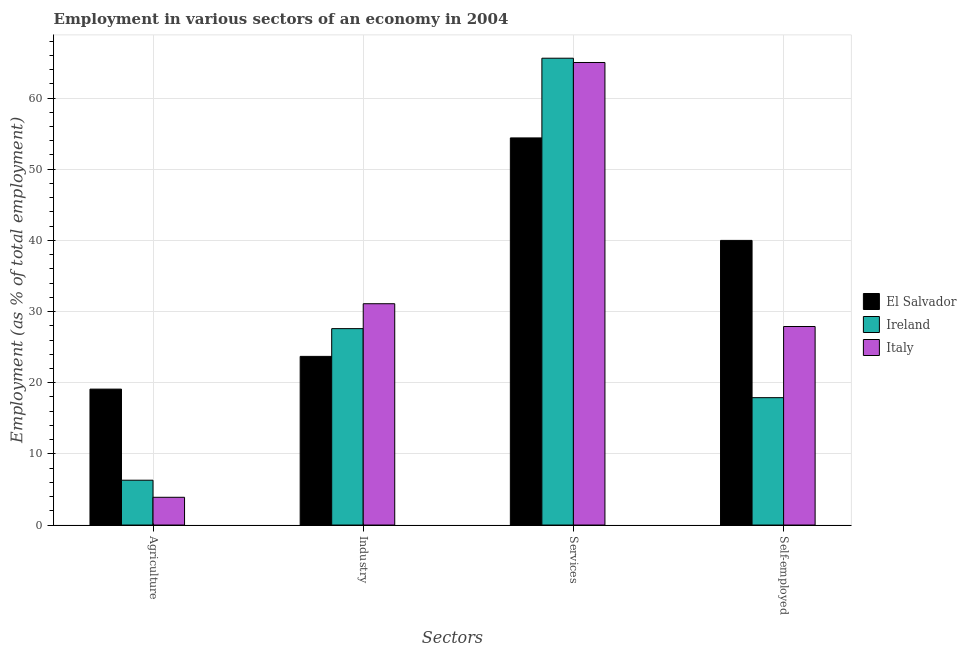How many groups of bars are there?
Offer a terse response. 4. Are the number of bars per tick equal to the number of legend labels?
Provide a succinct answer. Yes. Are the number of bars on each tick of the X-axis equal?
Your answer should be very brief. Yes. How many bars are there on the 1st tick from the left?
Keep it short and to the point. 3. What is the label of the 4th group of bars from the left?
Give a very brief answer. Self-employed. Across all countries, what is the maximum percentage of workers in agriculture?
Keep it short and to the point. 19.1. Across all countries, what is the minimum percentage of workers in industry?
Keep it short and to the point. 23.7. In which country was the percentage of workers in services maximum?
Give a very brief answer. Ireland. In which country was the percentage of workers in services minimum?
Offer a very short reply. El Salvador. What is the total percentage of self employed workers in the graph?
Offer a terse response. 85.8. What is the difference between the percentage of workers in agriculture in Italy and that in El Salvador?
Provide a succinct answer. -15.2. What is the difference between the percentage of workers in industry in Ireland and the percentage of self employed workers in El Salvador?
Offer a terse response. -12.4. What is the average percentage of workers in agriculture per country?
Provide a short and direct response. 9.77. What is the difference between the percentage of workers in services and percentage of workers in industry in Ireland?
Your response must be concise. 38. What is the ratio of the percentage of workers in agriculture in Ireland to that in El Salvador?
Your response must be concise. 0.33. Is the difference between the percentage of workers in agriculture in El Salvador and Italy greater than the difference between the percentage of workers in services in El Salvador and Italy?
Make the answer very short. Yes. What is the difference between the highest and the second highest percentage of self employed workers?
Your answer should be very brief. 12.1. What is the difference between the highest and the lowest percentage of self employed workers?
Your answer should be very brief. 22.1. In how many countries, is the percentage of workers in agriculture greater than the average percentage of workers in agriculture taken over all countries?
Give a very brief answer. 1. Is it the case that in every country, the sum of the percentage of workers in industry and percentage of workers in services is greater than the sum of percentage of workers in agriculture and percentage of self employed workers?
Your answer should be very brief. No. What does the 1st bar from the left in Services represents?
Your response must be concise. El Salvador. How many bars are there?
Your answer should be very brief. 12. Are all the bars in the graph horizontal?
Give a very brief answer. No. How many countries are there in the graph?
Your response must be concise. 3. What is the difference between two consecutive major ticks on the Y-axis?
Your answer should be compact. 10. Does the graph contain any zero values?
Offer a terse response. No. Does the graph contain grids?
Ensure brevity in your answer.  Yes. What is the title of the graph?
Provide a succinct answer. Employment in various sectors of an economy in 2004. What is the label or title of the X-axis?
Provide a succinct answer. Sectors. What is the label or title of the Y-axis?
Keep it short and to the point. Employment (as % of total employment). What is the Employment (as % of total employment) of El Salvador in Agriculture?
Your answer should be very brief. 19.1. What is the Employment (as % of total employment) in Ireland in Agriculture?
Offer a very short reply. 6.3. What is the Employment (as % of total employment) in Italy in Agriculture?
Provide a succinct answer. 3.9. What is the Employment (as % of total employment) in El Salvador in Industry?
Ensure brevity in your answer.  23.7. What is the Employment (as % of total employment) in Ireland in Industry?
Provide a short and direct response. 27.6. What is the Employment (as % of total employment) of Italy in Industry?
Make the answer very short. 31.1. What is the Employment (as % of total employment) of El Salvador in Services?
Provide a succinct answer. 54.4. What is the Employment (as % of total employment) in Ireland in Services?
Offer a terse response. 65.6. What is the Employment (as % of total employment) of El Salvador in Self-employed?
Your answer should be very brief. 40. What is the Employment (as % of total employment) of Ireland in Self-employed?
Your answer should be very brief. 17.9. What is the Employment (as % of total employment) in Italy in Self-employed?
Offer a terse response. 27.9. Across all Sectors, what is the maximum Employment (as % of total employment) of El Salvador?
Ensure brevity in your answer.  54.4. Across all Sectors, what is the maximum Employment (as % of total employment) of Ireland?
Your answer should be compact. 65.6. Across all Sectors, what is the maximum Employment (as % of total employment) of Italy?
Ensure brevity in your answer.  65. Across all Sectors, what is the minimum Employment (as % of total employment) in El Salvador?
Provide a short and direct response. 19.1. Across all Sectors, what is the minimum Employment (as % of total employment) in Ireland?
Make the answer very short. 6.3. Across all Sectors, what is the minimum Employment (as % of total employment) in Italy?
Your answer should be compact. 3.9. What is the total Employment (as % of total employment) in El Salvador in the graph?
Your answer should be very brief. 137.2. What is the total Employment (as % of total employment) in Ireland in the graph?
Provide a short and direct response. 117.4. What is the total Employment (as % of total employment) in Italy in the graph?
Keep it short and to the point. 127.9. What is the difference between the Employment (as % of total employment) in Ireland in Agriculture and that in Industry?
Ensure brevity in your answer.  -21.3. What is the difference between the Employment (as % of total employment) in Italy in Agriculture and that in Industry?
Your answer should be very brief. -27.2. What is the difference between the Employment (as % of total employment) of El Salvador in Agriculture and that in Services?
Make the answer very short. -35.3. What is the difference between the Employment (as % of total employment) in Ireland in Agriculture and that in Services?
Give a very brief answer. -59.3. What is the difference between the Employment (as % of total employment) of Italy in Agriculture and that in Services?
Offer a very short reply. -61.1. What is the difference between the Employment (as % of total employment) in El Salvador in Agriculture and that in Self-employed?
Offer a terse response. -20.9. What is the difference between the Employment (as % of total employment) of Ireland in Agriculture and that in Self-employed?
Provide a succinct answer. -11.6. What is the difference between the Employment (as % of total employment) of Italy in Agriculture and that in Self-employed?
Provide a succinct answer. -24. What is the difference between the Employment (as % of total employment) of El Salvador in Industry and that in Services?
Ensure brevity in your answer.  -30.7. What is the difference between the Employment (as % of total employment) in Ireland in Industry and that in Services?
Your answer should be very brief. -38. What is the difference between the Employment (as % of total employment) of Italy in Industry and that in Services?
Provide a succinct answer. -33.9. What is the difference between the Employment (as % of total employment) of El Salvador in Industry and that in Self-employed?
Provide a short and direct response. -16.3. What is the difference between the Employment (as % of total employment) in El Salvador in Services and that in Self-employed?
Ensure brevity in your answer.  14.4. What is the difference between the Employment (as % of total employment) in Ireland in Services and that in Self-employed?
Offer a very short reply. 47.7. What is the difference between the Employment (as % of total employment) of Italy in Services and that in Self-employed?
Make the answer very short. 37.1. What is the difference between the Employment (as % of total employment) in Ireland in Agriculture and the Employment (as % of total employment) in Italy in Industry?
Give a very brief answer. -24.8. What is the difference between the Employment (as % of total employment) of El Salvador in Agriculture and the Employment (as % of total employment) of Ireland in Services?
Make the answer very short. -46.5. What is the difference between the Employment (as % of total employment) of El Salvador in Agriculture and the Employment (as % of total employment) of Italy in Services?
Your answer should be very brief. -45.9. What is the difference between the Employment (as % of total employment) in Ireland in Agriculture and the Employment (as % of total employment) in Italy in Services?
Keep it short and to the point. -58.7. What is the difference between the Employment (as % of total employment) in El Salvador in Agriculture and the Employment (as % of total employment) in Ireland in Self-employed?
Your answer should be very brief. 1.2. What is the difference between the Employment (as % of total employment) of Ireland in Agriculture and the Employment (as % of total employment) of Italy in Self-employed?
Offer a very short reply. -21.6. What is the difference between the Employment (as % of total employment) in El Salvador in Industry and the Employment (as % of total employment) in Ireland in Services?
Provide a succinct answer. -41.9. What is the difference between the Employment (as % of total employment) of El Salvador in Industry and the Employment (as % of total employment) of Italy in Services?
Keep it short and to the point. -41.3. What is the difference between the Employment (as % of total employment) of Ireland in Industry and the Employment (as % of total employment) of Italy in Services?
Offer a terse response. -37.4. What is the difference between the Employment (as % of total employment) of El Salvador in Industry and the Employment (as % of total employment) of Italy in Self-employed?
Your answer should be compact. -4.2. What is the difference between the Employment (as % of total employment) of Ireland in Industry and the Employment (as % of total employment) of Italy in Self-employed?
Your answer should be very brief. -0.3. What is the difference between the Employment (as % of total employment) of El Salvador in Services and the Employment (as % of total employment) of Ireland in Self-employed?
Give a very brief answer. 36.5. What is the difference between the Employment (as % of total employment) in Ireland in Services and the Employment (as % of total employment) in Italy in Self-employed?
Ensure brevity in your answer.  37.7. What is the average Employment (as % of total employment) of El Salvador per Sectors?
Offer a terse response. 34.3. What is the average Employment (as % of total employment) of Ireland per Sectors?
Make the answer very short. 29.35. What is the average Employment (as % of total employment) of Italy per Sectors?
Offer a very short reply. 31.98. What is the difference between the Employment (as % of total employment) of Ireland and Employment (as % of total employment) of Italy in Agriculture?
Your response must be concise. 2.4. What is the difference between the Employment (as % of total employment) in El Salvador and Employment (as % of total employment) in Ireland in Industry?
Your response must be concise. -3.9. What is the difference between the Employment (as % of total employment) of Ireland and Employment (as % of total employment) of Italy in Industry?
Your answer should be very brief. -3.5. What is the difference between the Employment (as % of total employment) of El Salvador and Employment (as % of total employment) of Ireland in Services?
Provide a short and direct response. -11.2. What is the difference between the Employment (as % of total employment) of Ireland and Employment (as % of total employment) of Italy in Services?
Give a very brief answer. 0.6. What is the difference between the Employment (as % of total employment) in El Salvador and Employment (as % of total employment) in Ireland in Self-employed?
Make the answer very short. 22.1. What is the difference between the Employment (as % of total employment) in El Salvador and Employment (as % of total employment) in Italy in Self-employed?
Your response must be concise. 12.1. What is the difference between the Employment (as % of total employment) in Ireland and Employment (as % of total employment) in Italy in Self-employed?
Ensure brevity in your answer.  -10. What is the ratio of the Employment (as % of total employment) in El Salvador in Agriculture to that in Industry?
Ensure brevity in your answer.  0.81. What is the ratio of the Employment (as % of total employment) in Ireland in Agriculture to that in Industry?
Provide a short and direct response. 0.23. What is the ratio of the Employment (as % of total employment) of Italy in Agriculture to that in Industry?
Give a very brief answer. 0.13. What is the ratio of the Employment (as % of total employment) of El Salvador in Agriculture to that in Services?
Offer a terse response. 0.35. What is the ratio of the Employment (as % of total employment) of Ireland in Agriculture to that in Services?
Offer a terse response. 0.1. What is the ratio of the Employment (as % of total employment) in Italy in Agriculture to that in Services?
Provide a short and direct response. 0.06. What is the ratio of the Employment (as % of total employment) in El Salvador in Agriculture to that in Self-employed?
Provide a short and direct response. 0.48. What is the ratio of the Employment (as % of total employment) in Ireland in Agriculture to that in Self-employed?
Your answer should be compact. 0.35. What is the ratio of the Employment (as % of total employment) of Italy in Agriculture to that in Self-employed?
Your response must be concise. 0.14. What is the ratio of the Employment (as % of total employment) in El Salvador in Industry to that in Services?
Offer a very short reply. 0.44. What is the ratio of the Employment (as % of total employment) of Ireland in Industry to that in Services?
Provide a short and direct response. 0.42. What is the ratio of the Employment (as % of total employment) of Italy in Industry to that in Services?
Offer a very short reply. 0.48. What is the ratio of the Employment (as % of total employment) of El Salvador in Industry to that in Self-employed?
Give a very brief answer. 0.59. What is the ratio of the Employment (as % of total employment) in Ireland in Industry to that in Self-employed?
Your response must be concise. 1.54. What is the ratio of the Employment (as % of total employment) of Italy in Industry to that in Self-employed?
Give a very brief answer. 1.11. What is the ratio of the Employment (as % of total employment) of El Salvador in Services to that in Self-employed?
Offer a terse response. 1.36. What is the ratio of the Employment (as % of total employment) in Ireland in Services to that in Self-employed?
Keep it short and to the point. 3.66. What is the ratio of the Employment (as % of total employment) of Italy in Services to that in Self-employed?
Ensure brevity in your answer.  2.33. What is the difference between the highest and the second highest Employment (as % of total employment) in El Salvador?
Provide a short and direct response. 14.4. What is the difference between the highest and the second highest Employment (as % of total employment) of Italy?
Provide a succinct answer. 33.9. What is the difference between the highest and the lowest Employment (as % of total employment) of El Salvador?
Ensure brevity in your answer.  35.3. What is the difference between the highest and the lowest Employment (as % of total employment) in Ireland?
Your answer should be very brief. 59.3. What is the difference between the highest and the lowest Employment (as % of total employment) in Italy?
Provide a succinct answer. 61.1. 